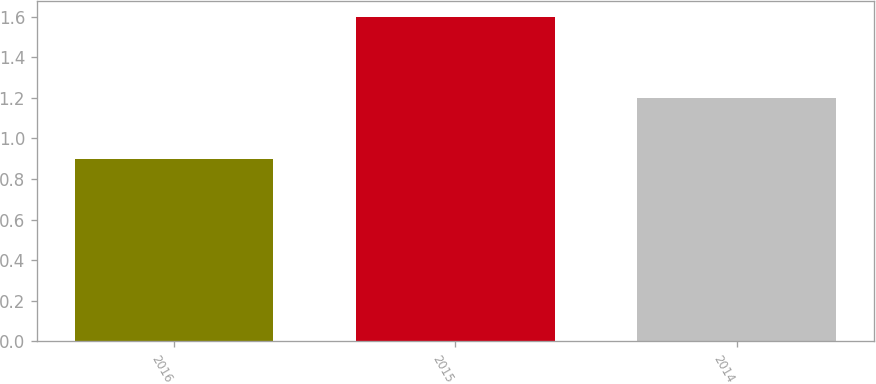<chart> <loc_0><loc_0><loc_500><loc_500><bar_chart><fcel>2016<fcel>2015<fcel>2014<nl><fcel>0.9<fcel>1.6<fcel>1.2<nl></chart> 